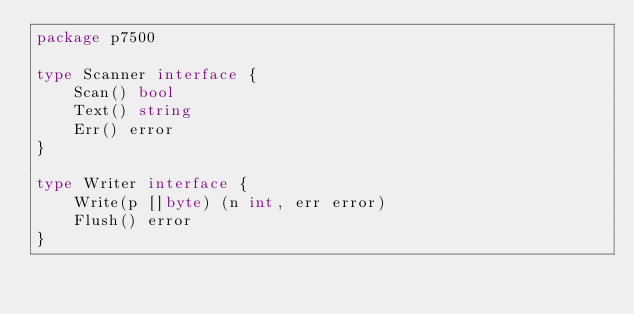Convert code to text. <code><loc_0><loc_0><loc_500><loc_500><_Go_>package p7500

type Scanner interface {
	Scan() bool
	Text() string
	Err() error
}

type Writer interface {
	Write(p []byte) (n int, err error)
	Flush() error
}
</code> 